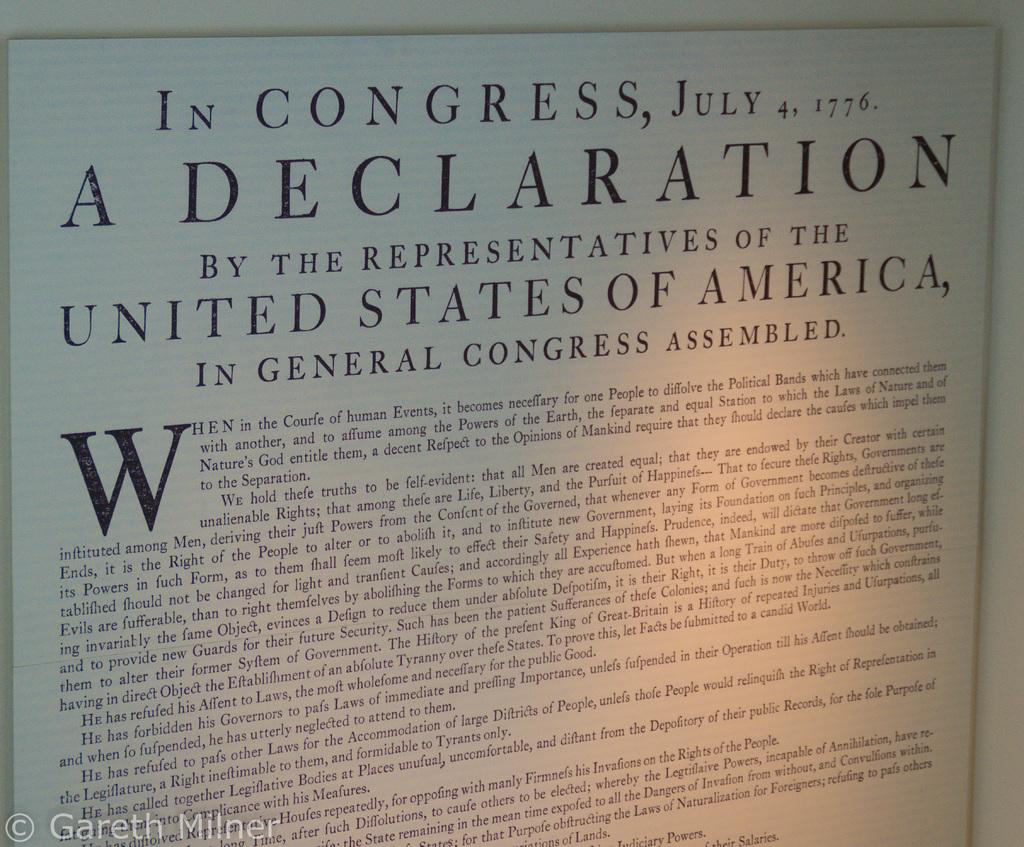What country is on this document?
Give a very brief answer. United states of america. 